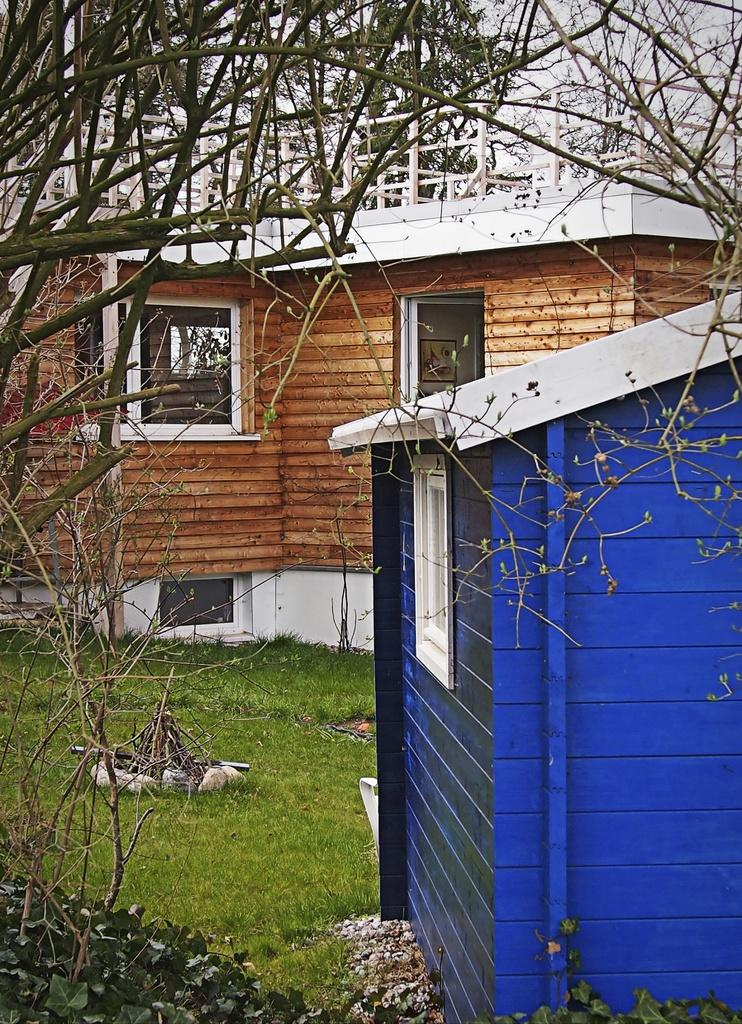How many buildings can be seen in the image? There are two buildings in the image. What feature do the buildings have in common? The buildings have windows. What type of surface is visible on the floor? There is grass on the floor. What type of vegetation is present in the image? There are plants and trees in the image. What is the condition of the sky in the image? The sky is clear in the image. What type of print can be seen on the buildings in the image? There is no specific print visible on the buildings in the image; they appear to have a uniform color or texture. What type of system is responsible for the clear sky in the image? The clear sky in the image is a result of weather conditions and not a specific system. 